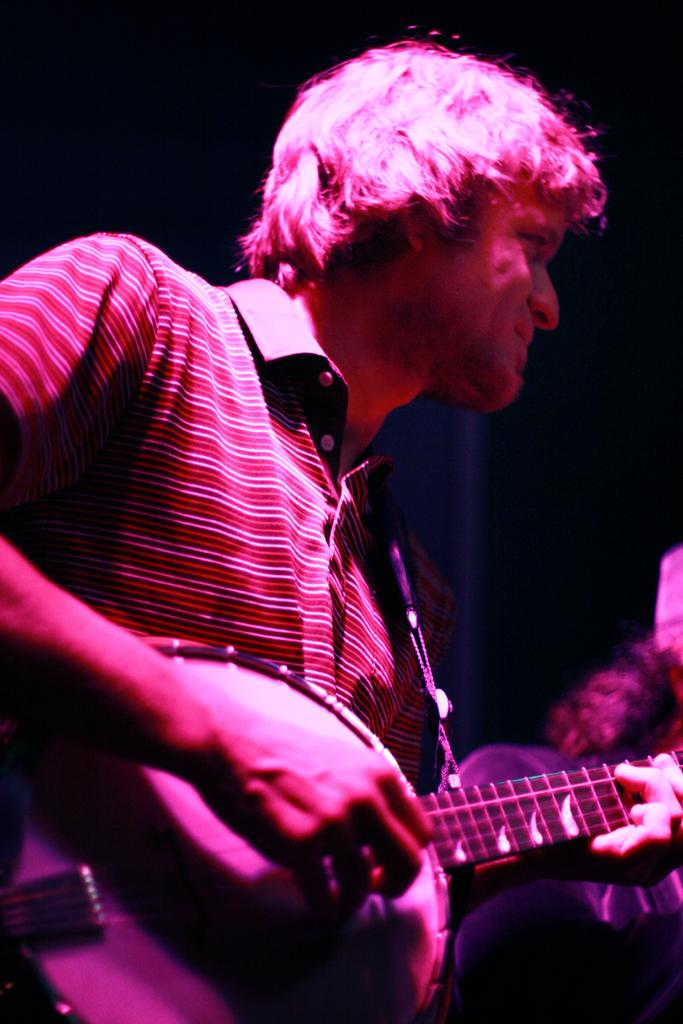What is the main subject of the image? There is a guy playing a guitar in the image. Where was the image taken? The image is taken at a concert. Are there any other people visible in the image? Yes, there are people standing to the right side of the image. What type of drug can be seen in the hands of the guitar player in the image? There is no drug present in the image; the guitar player is holding a guitar. What kind of paper is being used by the audience to write down the lyrics of the songs? There is no paper visible in the image, nor is there any indication that the audience is writing down lyrics. 